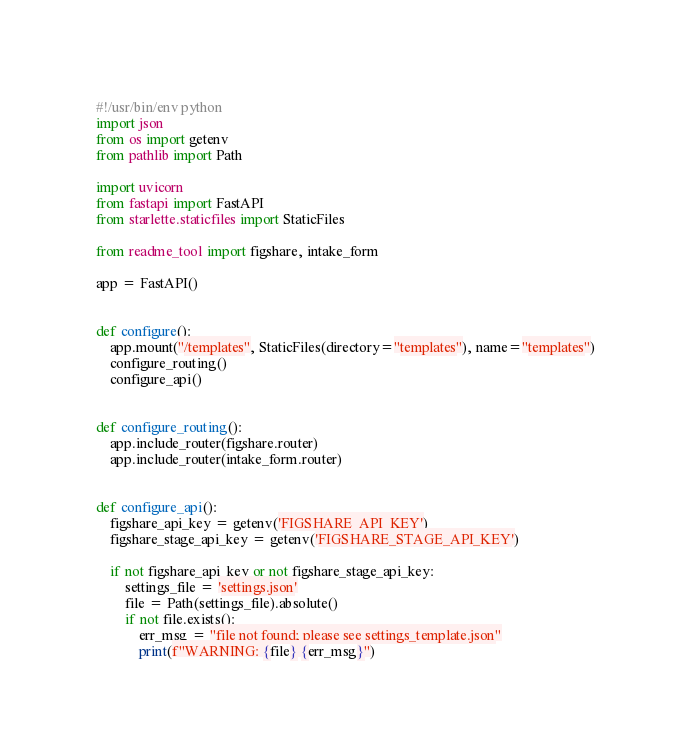<code> <loc_0><loc_0><loc_500><loc_500><_Python_>#!/usr/bin/env python
import json
from os import getenv
from pathlib import Path

import uvicorn
from fastapi import FastAPI
from starlette.staticfiles import StaticFiles

from readme_tool import figshare, intake_form

app = FastAPI()


def configure():
    app.mount("/templates", StaticFiles(directory="templates"), name="templates")
    configure_routing()
    configure_api()


def configure_routing():
    app.include_router(figshare.router)
    app.include_router(intake_form.router)


def configure_api():
    figshare_api_key = getenv('FIGSHARE_API_KEY')
    figshare_stage_api_key = getenv('FIGSHARE_STAGE_API_KEY')

    if not figshare_api_key or not figshare_stage_api_key:
        settings_file = 'settings.json'
        file = Path(settings_file).absolute()
        if not file.exists():
            err_msg = "file not found; please see settings_template.json"
            print(f"WARNING: {file} {err_msg}")</code> 